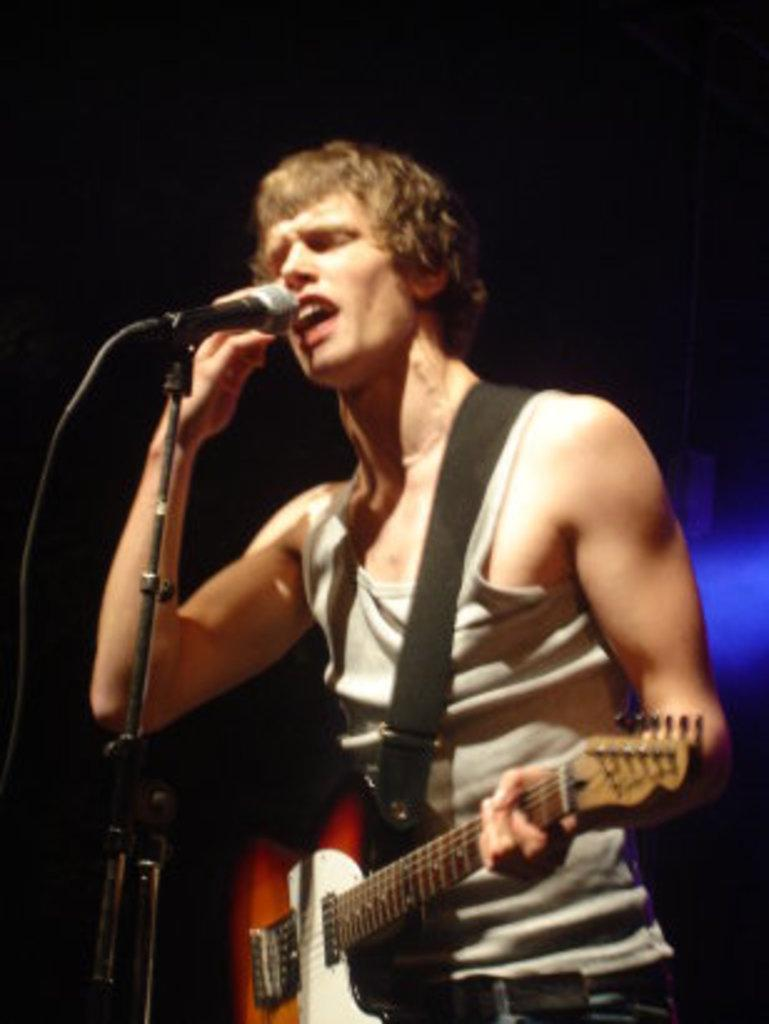What is the main subject of the image? There is a person in the image. What is the person doing in the image? The person is standing in front of a mic. What object is the person holding in the image? The person is holding a guitar. What type of nest can be seen in the image? There is no nest present in the image; it features a person standing in front of a mic and holding a guitar. How many men are visible in the image? The image only shows one person, so there is only one man visible. 